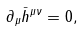Convert formula to latex. <formula><loc_0><loc_0><loc_500><loc_500>\partial _ { \mu } \bar { h } ^ { \mu \nu } = 0 ,</formula> 